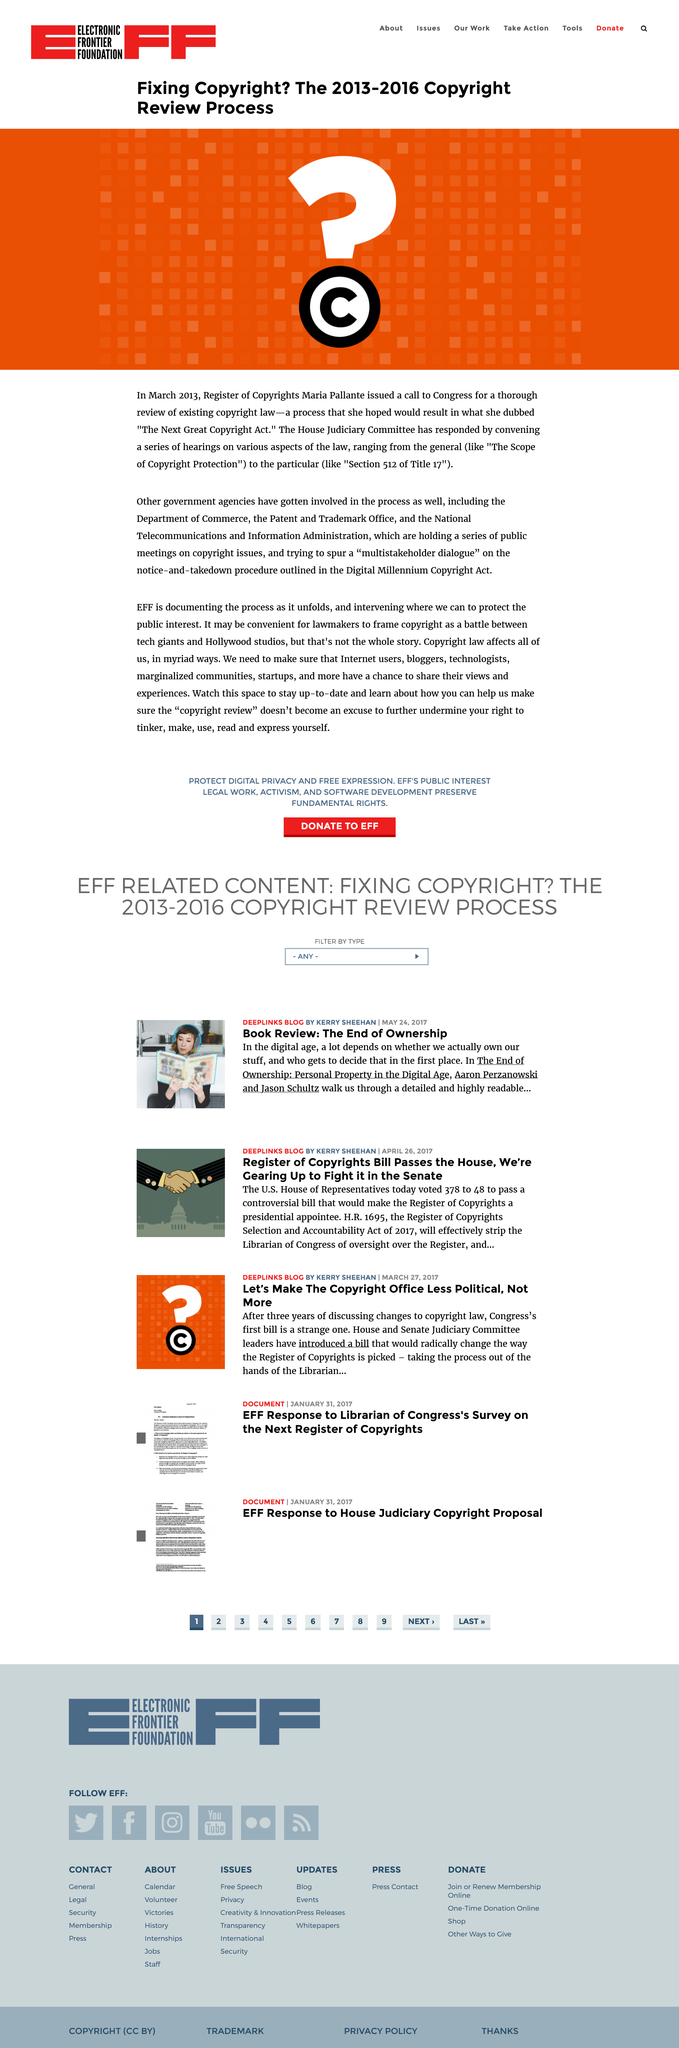Specify some key components in this picture. The review of existing copyright laws, known as "The Next Great Copyright Act," took place in March 2013. The review of existing copyright law in March 2013 was given the name "The Next Great Copyright Act. In March 2013, Maria Pallante was the Register of Copyrights. 